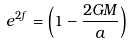<formula> <loc_0><loc_0><loc_500><loc_500>e ^ { 2 f } = \left ( 1 - \frac { 2 G M } { a } \right )</formula> 